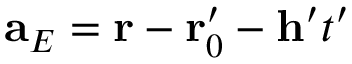<formula> <loc_0><loc_0><loc_500><loc_500>a _ { E } = r - r _ { 0 } ^ { \prime } - h ^ { \prime } t ^ { \prime }</formula> 